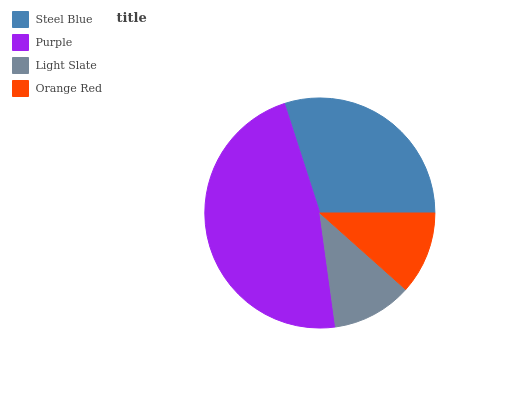Is Light Slate the minimum?
Answer yes or no. Yes. Is Purple the maximum?
Answer yes or no. Yes. Is Purple the minimum?
Answer yes or no. No. Is Light Slate the maximum?
Answer yes or no. No. Is Purple greater than Light Slate?
Answer yes or no. Yes. Is Light Slate less than Purple?
Answer yes or no. Yes. Is Light Slate greater than Purple?
Answer yes or no. No. Is Purple less than Light Slate?
Answer yes or no. No. Is Steel Blue the high median?
Answer yes or no. Yes. Is Orange Red the low median?
Answer yes or no. Yes. Is Purple the high median?
Answer yes or no. No. Is Purple the low median?
Answer yes or no. No. 